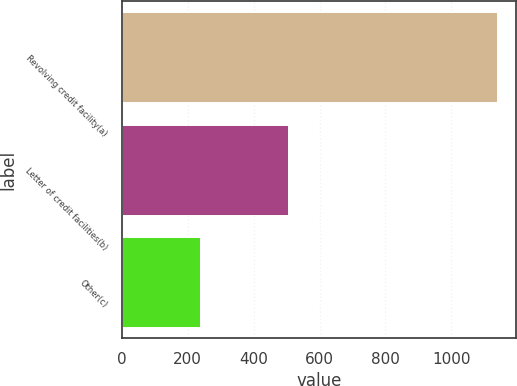Convert chart to OTSL. <chart><loc_0><loc_0><loc_500><loc_500><bar_chart><fcel>Revolving credit facility(a)<fcel>Letter of credit facilities(b)<fcel>Other(c)<nl><fcel>1138<fcel>505<fcel>237<nl></chart> 